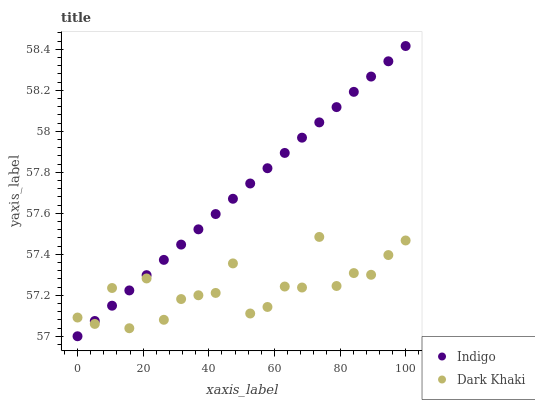Does Dark Khaki have the minimum area under the curve?
Answer yes or no. Yes. Does Indigo have the maximum area under the curve?
Answer yes or no. Yes. Does Indigo have the minimum area under the curve?
Answer yes or no. No. Is Indigo the smoothest?
Answer yes or no. Yes. Is Dark Khaki the roughest?
Answer yes or no. Yes. Is Indigo the roughest?
Answer yes or no. No. Does Indigo have the lowest value?
Answer yes or no. Yes. Does Indigo have the highest value?
Answer yes or no. Yes. Does Indigo intersect Dark Khaki?
Answer yes or no. Yes. Is Indigo less than Dark Khaki?
Answer yes or no. No. Is Indigo greater than Dark Khaki?
Answer yes or no. No. 